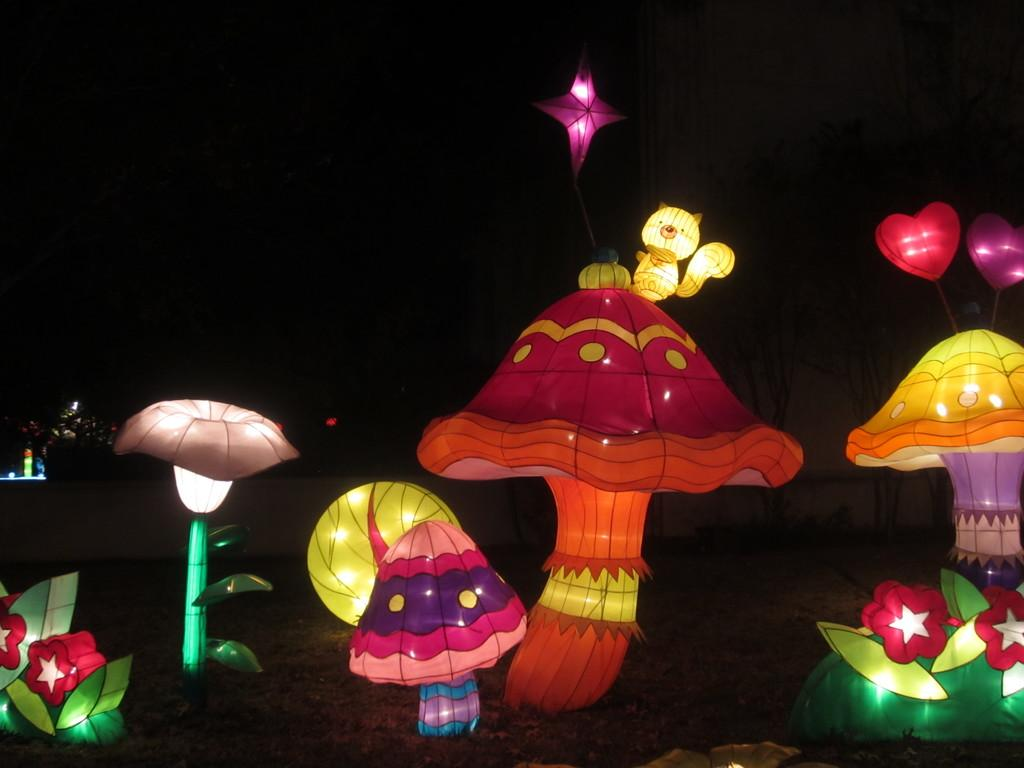What is the main subject of the image? The main subject of the image is paper lanterns. Where are the paper lanterns located in the image? The paper lanterns are in the center of the image. What type of pan is being used to cook the sun in the image? There is no pan or sun present in the image; it features paper lanterns. How many baseballs can be seen in the image? There are no baseballs present in the image. 